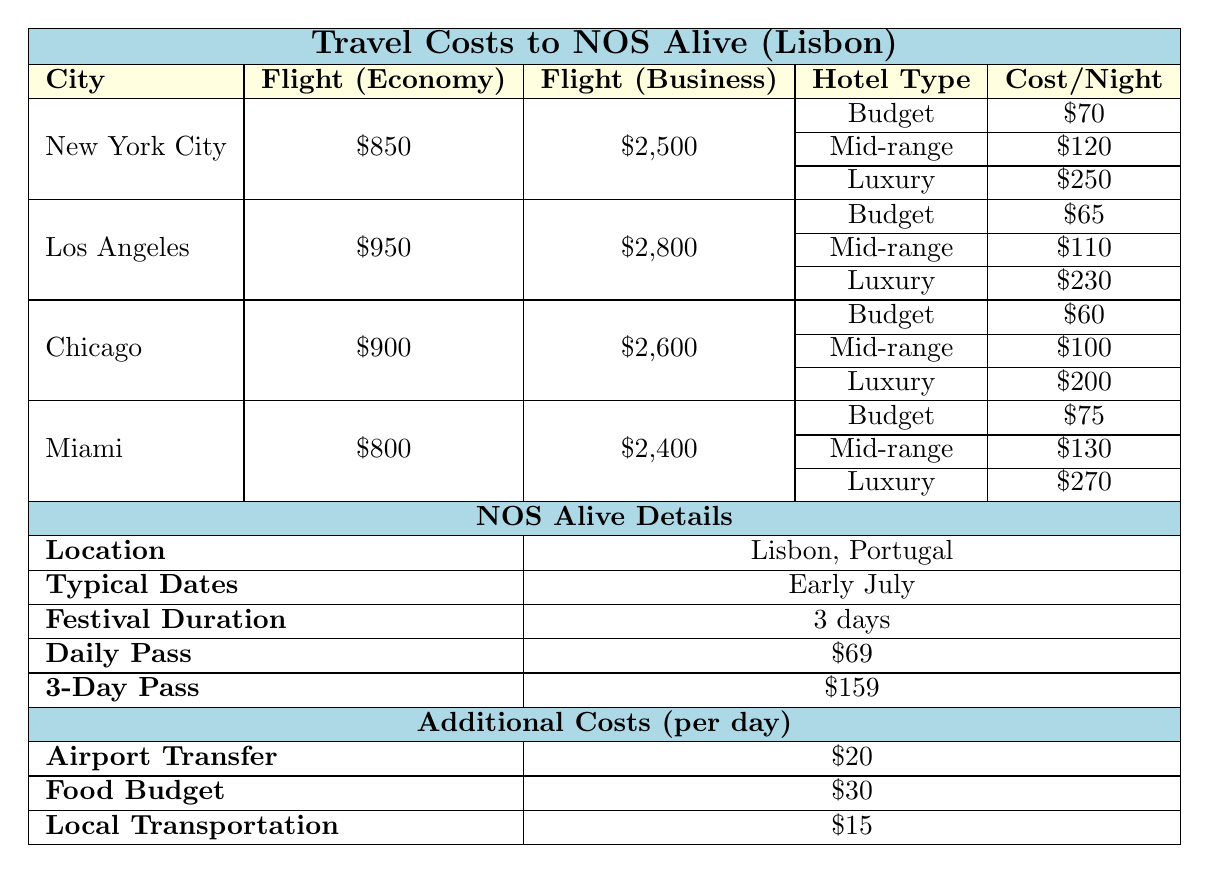What is the flight cost from New York City for economy class? The table provides the flight costs for New York City, which lists the economy flight cost as $850.
Answer: $850 What is the daily cost for food during the trip? The table states that the food budget is $30 per day, which is an additional cost.
Answer: $30 What is the total cost for a 3-day stay at a mid-range hotel in Chicago, including hotel and additional costs? The cost per night for a mid-range hotel in Chicago is $100. For 3 days, it totals $300. Adding the daily costs for food ($30), airport transfer ($20), and local transportation ($15) gives an additional $65 for 3 days, totaling $365, which leads to $300 + $65 = $365.
Answer: $365 Is the flight cost for Los Angeles higher than for Miami in economy class? The economy flight cost for Los Angeles is $950, while for Miami it is $800. Since $950 is greater than $800, the statement is true.
Answer: Yes What is the difference in business flight costs between New York City and Chicago? The business flight cost for New York City is $2,500, and for Chicago, it is $2,600. The difference is $2,600 - $2,500 = $100.
Answer: $100 If a visitor stays in a luxury hotel in Miami for 3 nights, what is the total accommodation cost? The cost per night for a luxury hotel in Miami is $270. For 3 nights, it would be 3 x $270 = $810.
Answer: $810 What is the total cost for attending NOS Alive for 3 days, including the festival pass and accommodation in a budget hotel from New York City? The cost for a 3-day festival pass is $159. The budget hotel costs $70 per night, so for 3 nights, it would be 3 x $70 = $210. Therefore, total cost $159 + $210 = $369.
Answer: $369 Which city has the highest economy flight cost? The table shows economy flight costs: New York City at $850, Los Angeles at $950, Chicago at $900, and Miami at $800. Los Angeles has the highest cost at $950.
Answer: Los Angeles If a traveler chooses a luxury hotel in Los Angeles, what is the total cost for 2 nights including the hotel and daily food? The cost per night for a luxury hotel in Los Angeles is $230. For 2 nights, it totals $460. With a daily food budget of $30 for 2 days, the additional cost is $60. Therefore, $460 + $60 = $520.
Answer: $520 Does the cost for a daily pass for NOS Alive exceed the daily food budget? The daily pass costs $69, while the daily food budget is $30. Since $69 is greater than $30, the statement is true.
Answer: Yes 